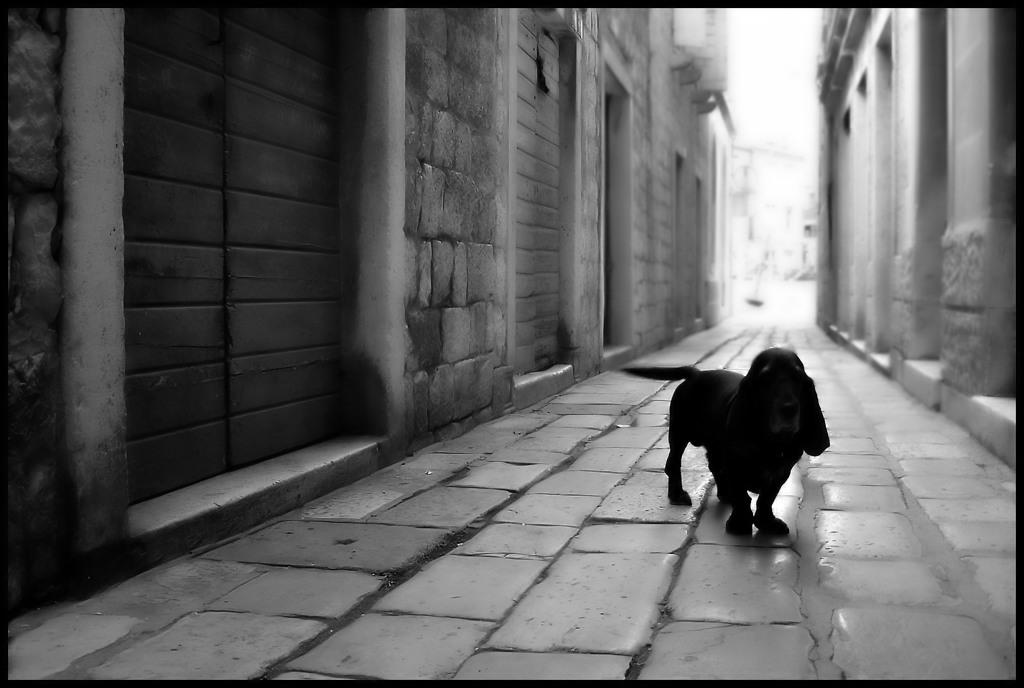What animal is standing in the image? There is a dog standing in the image. What can be seen on both sides of the image? There are buildings on both the right and left sides of the image. What is the color scheme of the image? The image is black and white. What type of metal is the dog made of in the image? The dog is not made of metal; it is a living animal. The image is black and white, so it is not possible to determine the material of the dog from the image. 